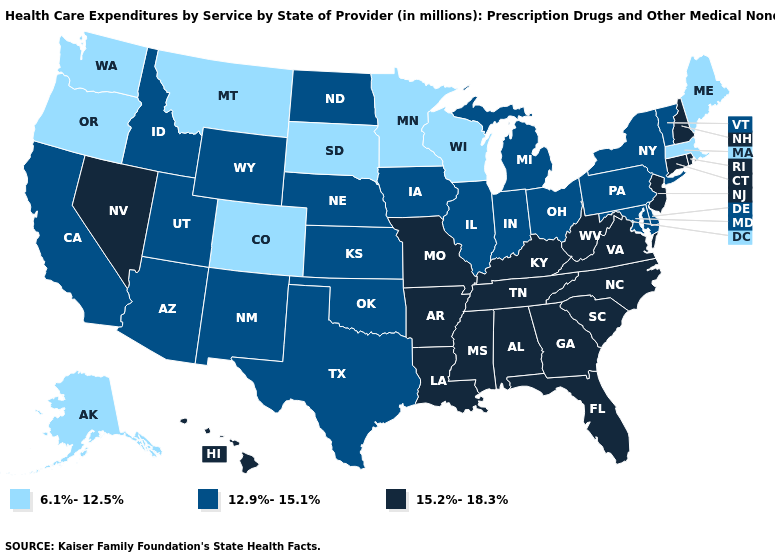Which states have the highest value in the USA?
Short answer required. Alabama, Arkansas, Connecticut, Florida, Georgia, Hawaii, Kentucky, Louisiana, Mississippi, Missouri, Nevada, New Hampshire, New Jersey, North Carolina, Rhode Island, South Carolina, Tennessee, Virginia, West Virginia. Which states hav the highest value in the South?
Quick response, please. Alabama, Arkansas, Florida, Georgia, Kentucky, Louisiana, Mississippi, North Carolina, South Carolina, Tennessee, Virginia, West Virginia. Does Washington have the highest value in the USA?
Answer briefly. No. Name the states that have a value in the range 12.9%-15.1%?
Write a very short answer. Arizona, California, Delaware, Idaho, Illinois, Indiana, Iowa, Kansas, Maryland, Michigan, Nebraska, New Mexico, New York, North Dakota, Ohio, Oklahoma, Pennsylvania, Texas, Utah, Vermont, Wyoming. What is the value of Florida?
Concise answer only. 15.2%-18.3%. Name the states that have a value in the range 6.1%-12.5%?
Give a very brief answer. Alaska, Colorado, Maine, Massachusetts, Minnesota, Montana, Oregon, South Dakota, Washington, Wisconsin. Does Michigan have a higher value than Alaska?
Be succinct. Yes. Among the states that border Indiana , does Michigan have the highest value?
Keep it brief. No. What is the value of Florida?
Write a very short answer. 15.2%-18.3%. What is the value of West Virginia?
Answer briefly. 15.2%-18.3%. Does Nebraska have the lowest value in the USA?
Concise answer only. No. Does Arkansas have the lowest value in the South?
Keep it brief. No. Which states have the highest value in the USA?
Be succinct. Alabama, Arkansas, Connecticut, Florida, Georgia, Hawaii, Kentucky, Louisiana, Mississippi, Missouri, Nevada, New Hampshire, New Jersey, North Carolina, Rhode Island, South Carolina, Tennessee, Virginia, West Virginia. Does South Carolina have the lowest value in the USA?
Be succinct. No. What is the lowest value in states that border Maryland?
Keep it brief. 12.9%-15.1%. 